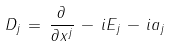Convert formula to latex. <formula><loc_0><loc_0><loc_500><loc_500>D _ { j } \, = \, \frac { \partial } { \partial x ^ { j } } \, - \, i E _ { j } \, - \, i a _ { j }</formula> 